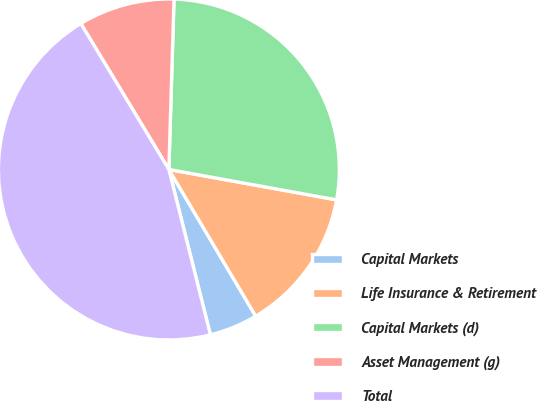Convert chart. <chart><loc_0><loc_0><loc_500><loc_500><pie_chart><fcel>Capital Markets<fcel>Life Insurance & Retirement<fcel>Capital Markets (d)<fcel>Asset Management (g)<fcel>Total<nl><fcel>4.59%<fcel>13.64%<fcel>27.37%<fcel>9.12%<fcel>45.28%<nl></chart> 